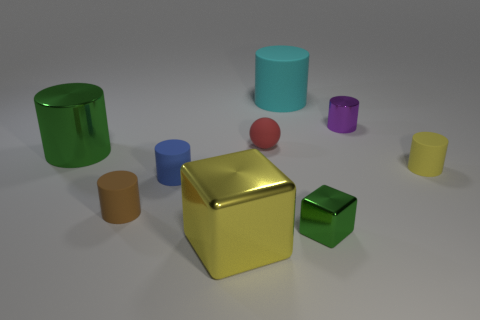Are there any other things that have the same material as the small purple thing?
Your response must be concise. Yes. Is there a cyan shiny cube?
Offer a terse response. No. There is a large matte cylinder; does it have the same color as the small matte cylinder that is on the right side of the small green object?
Provide a short and direct response. No. There is a green thing that is on the right side of the green metal thing behind the tiny matte object to the right of the small green shiny block; how big is it?
Provide a succinct answer. Small. How many large metallic objects have the same color as the small metal cube?
Keep it short and to the point. 1. What number of objects are large green objects or shiny objects that are in front of the tiny brown object?
Offer a very short reply. 3. The small metallic cylinder is what color?
Keep it short and to the point. Purple. There is a rubber cylinder that is behind the red sphere; what color is it?
Offer a terse response. Cyan. How many small shiny things are in front of the cube that is left of the tiny red matte sphere?
Make the answer very short. 0. Does the cyan cylinder have the same size as the green thing that is right of the red matte object?
Provide a short and direct response. No. 